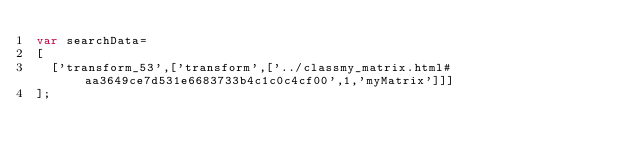Convert code to text. <code><loc_0><loc_0><loc_500><loc_500><_JavaScript_>var searchData=
[
  ['transform_53',['transform',['../classmy_matrix.html#aa3649ce7d531e6683733b4c1c0c4cf00',1,'myMatrix']]]
];
</code> 